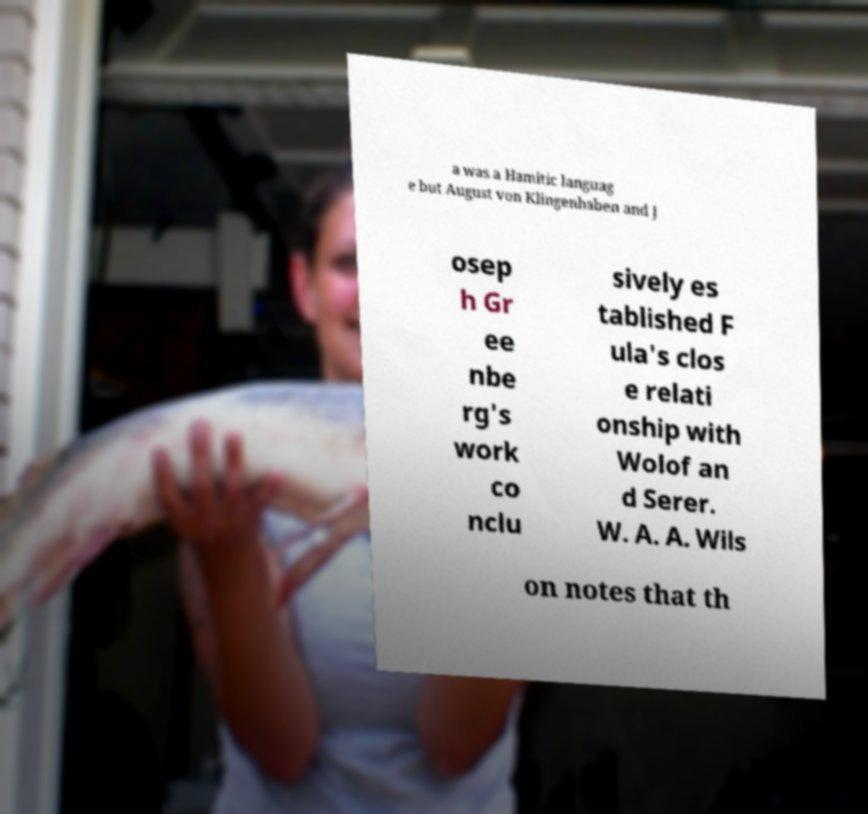Could you extract and type out the text from this image? a was a Hamitic languag e but August von Klingenhaben and J osep h Gr ee nbe rg's work co nclu sively es tablished F ula's clos e relati onship with Wolof an d Serer. W. A. A. Wils on notes that th 